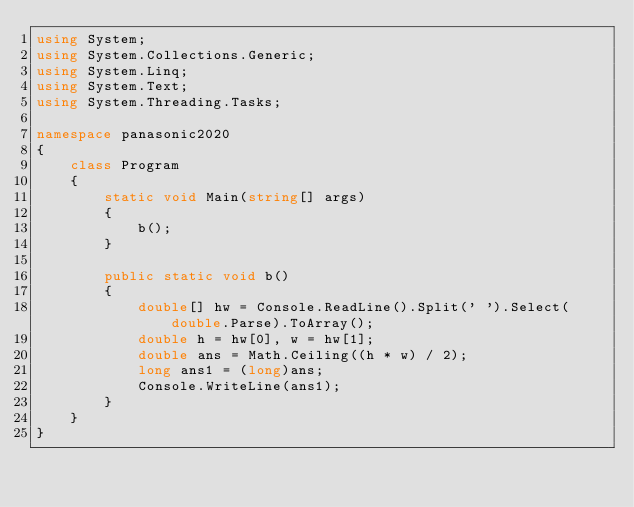Convert code to text. <code><loc_0><loc_0><loc_500><loc_500><_C#_>using System;
using System.Collections.Generic;
using System.Linq;
using System.Text;
using System.Threading.Tasks;

namespace panasonic2020
{
    class Program
    {
        static void Main(string[] args)
        {
            b();
        }

        public static void b()
        {
            double[] hw = Console.ReadLine().Split(' ').Select(double.Parse).ToArray();
            double h = hw[0], w = hw[1];
            double ans = Math.Ceiling((h * w) / 2);
            long ans1 = (long)ans;
            Console.WriteLine(ans1);
        }
    }
}
</code> 